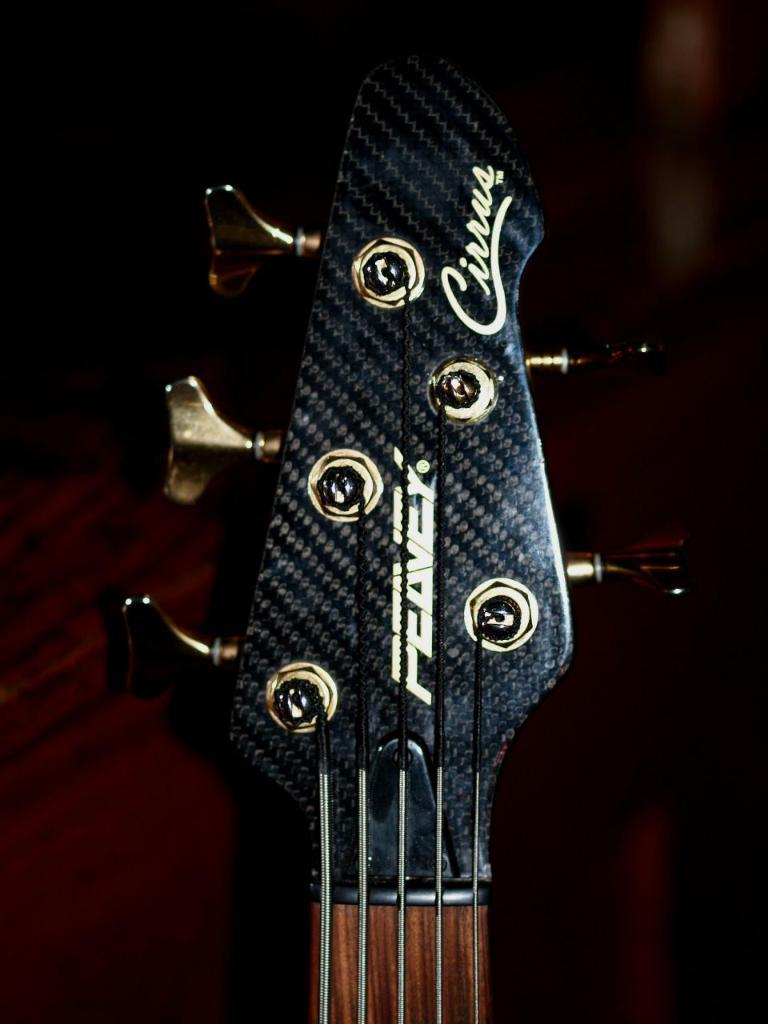What musical instrument is present in the image? There is a guitar in the image. What feature of the guitar can be seen in the image? The guitar has keys. What type of spark can be seen coming from the guitar in the image? There is no spark present in the image; the guitar has keys, not a spark. 